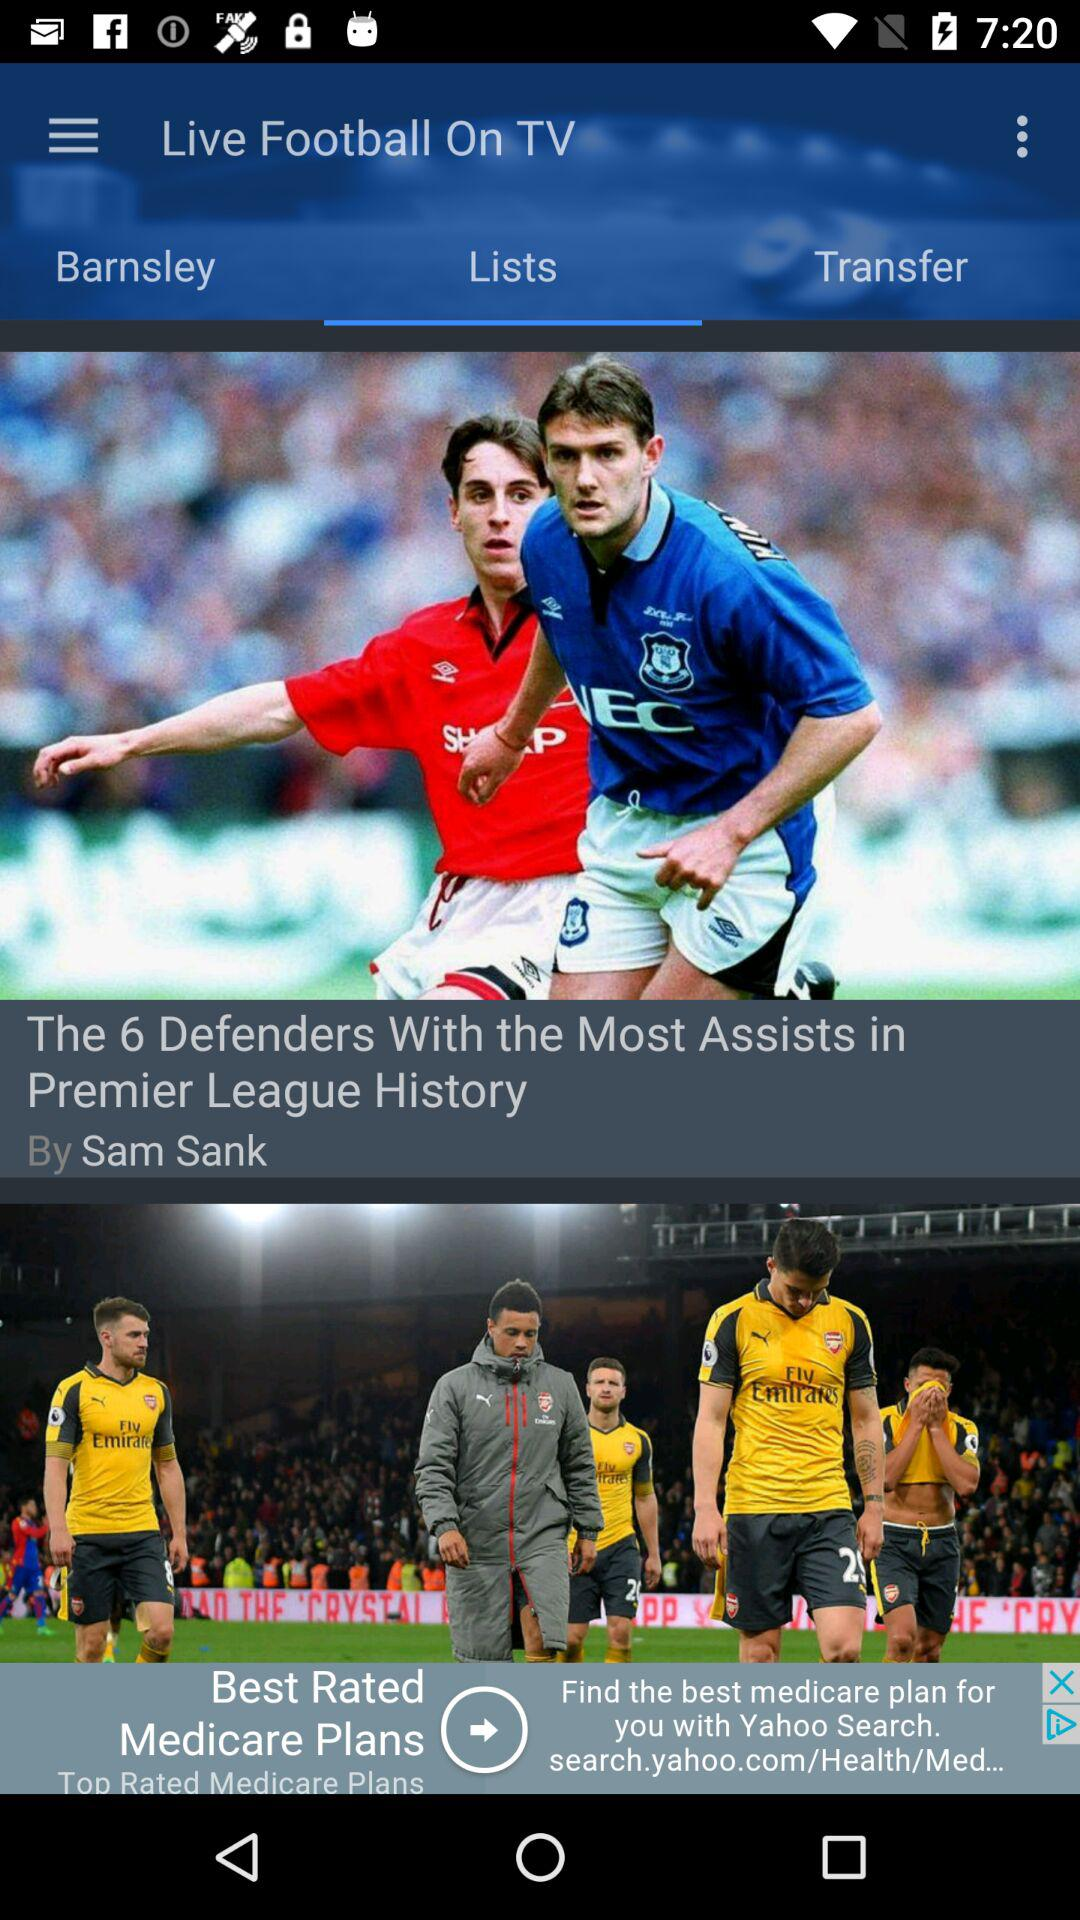Which tab is open? The open tab is "Lists". 